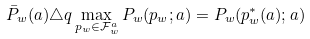Convert formula to latex. <formula><loc_0><loc_0><loc_500><loc_500>\bar { P } _ { w } ( a ) \triangle q \max _ { p _ { w } \in \mathcal { F } ^ { a } _ { w } } P _ { w } ( p _ { w } ; a ) = P _ { w } ( p ^ { * } _ { w } ( a ) ; a )</formula> 